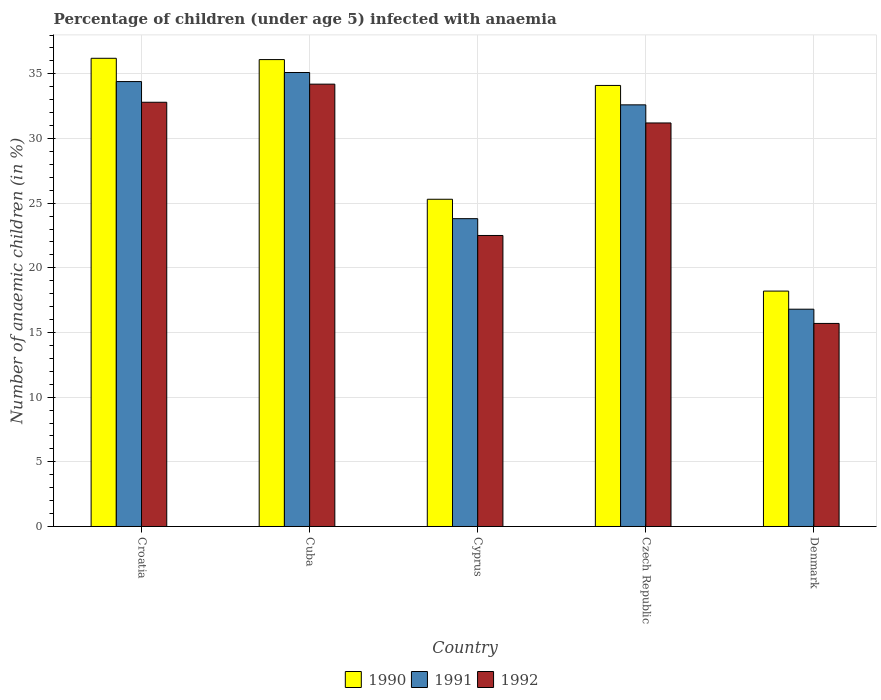How many different coloured bars are there?
Offer a terse response. 3. How many groups of bars are there?
Make the answer very short. 5. Are the number of bars per tick equal to the number of legend labels?
Your response must be concise. Yes. How many bars are there on the 1st tick from the left?
Your response must be concise. 3. How many bars are there on the 3rd tick from the right?
Give a very brief answer. 3. What is the label of the 4th group of bars from the left?
Provide a succinct answer. Czech Republic. What is the percentage of children infected with anaemia in in 1992 in Cuba?
Give a very brief answer. 34.2. Across all countries, what is the maximum percentage of children infected with anaemia in in 1990?
Make the answer very short. 36.2. Across all countries, what is the minimum percentage of children infected with anaemia in in 1991?
Ensure brevity in your answer.  16.8. In which country was the percentage of children infected with anaemia in in 1990 maximum?
Ensure brevity in your answer.  Croatia. In which country was the percentage of children infected with anaemia in in 1992 minimum?
Give a very brief answer. Denmark. What is the total percentage of children infected with anaemia in in 1992 in the graph?
Provide a succinct answer. 136.4. What is the difference between the percentage of children infected with anaemia in in 1991 in Croatia and that in Cuba?
Give a very brief answer. -0.7. What is the difference between the percentage of children infected with anaemia in in 1991 in Cyprus and the percentage of children infected with anaemia in in 1990 in Czech Republic?
Your answer should be compact. -10.3. What is the average percentage of children infected with anaemia in in 1992 per country?
Your response must be concise. 27.28. What is the difference between the percentage of children infected with anaemia in of/in 1991 and percentage of children infected with anaemia in of/in 1992 in Cuba?
Your answer should be compact. 0.9. What is the ratio of the percentage of children infected with anaemia in in 1992 in Cuba to that in Denmark?
Offer a very short reply. 2.18. Is the percentage of children infected with anaemia in in 1992 in Croatia less than that in Denmark?
Ensure brevity in your answer.  No. Is the difference between the percentage of children infected with anaemia in in 1991 in Cuba and Denmark greater than the difference between the percentage of children infected with anaemia in in 1992 in Cuba and Denmark?
Ensure brevity in your answer.  No. What is the difference between the highest and the second highest percentage of children infected with anaemia in in 1990?
Your response must be concise. -2.1. What is the difference between the highest and the lowest percentage of children infected with anaemia in in 1992?
Make the answer very short. 18.5. In how many countries, is the percentage of children infected with anaemia in in 1990 greater than the average percentage of children infected with anaemia in in 1990 taken over all countries?
Offer a very short reply. 3. Is the sum of the percentage of children infected with anaemia in in 1991 in Cyprus and Denmark greater than the maximum percentage of children infected with anaemia in in 1990 across all countries?
Your response must be concise. Yes. What does the 1st bar from the left in Cyprus represents?
Ensure brevity in your answer.  1990. Is it the case that in every country, the sum of the percentage of children infected with anaemia in in 1990 and percentage of children infected with anaemia in in 1991 is greater than the percentage of children infected with anaemia in in 1992?
Offer a terse response. Yes. Are all the bars in the graph horizontal?
Give a very brief answer. No. What is the difference between two consecutive major ticks on the Y-axis?
Give a very brief answer. 5. Does the graph contain any zero values?
Your answer should be compact. No. Does the graph contain grids?
Ensure brevity in your answer.  Yes. Where does the legend appear in the graph?
Offer a terse response. Bottom center. How are the legend labels stacked?
Your answer should be very brief. Horizontal. What is the title of the graph?
Keep it short and to the point. Percentage of children (under age 5) infected with anaemia. What is the label or title of the X-axis?
Provide a short and direct response. Country. What is the label or title of the Y-axis?
Ensure brevity in your answer.  Number of anaemic children (in %). What is the Number of anaemic children (in %) of 1990 in Croatia?
Offer a very short reply. 36.2. What is the Number of anaemic children (in %) in 1991 in Croatia?
Keep it short and to the point. 34.4. What is the Number of anaemic children (in %) of 1992 in Croatia?
Your response must be concise. 32.8. What is the Number of anaemic children (in %) in 1990 in Cuba?
Offer a very short reply. 36.1. What is the Number of anaemic children (in %) of 1991 in Cuba?
Ensure brevity in your answer.  35.1. What is the Number of anaemic children (in %) of 1992 in Cuba?
Your answer should be very brief. 34.2. What is the Number of anaemic children (in %) in 1990 in Cyprus?
Ensure brevity in your answer.  25.3. What is the Number of anaemic children (in %) in 1991 in Cyprus?
Offer a very short reply. 23.8. What is the Number of anaemic children (in %) in 1990 in Czech Republic?
Offer a terse response. 34.1. What is the Number of anaemic children (in %) of 1991 in Czech Republic?
Ensure brevity in your answer.  32.6. What is the Number of anaemic children (in %) in 1992 in Czech Republic?
Make the answer very short. 31.2. Across all countries, what is the maximum Number of anaemic children (in %) of 1990?
Give a very brief answer. 36.2. Across all countries, what is the maximum Number of anaemic children (in %) in 1991?
Give a very brief answer. 35.1. Across all countries, what is the maximum Number of anaemic children (in %) of 1992?
Ensure brevity in your answer.  34.2. Across all countries, what is the minimum Number of anaemic children (in %) of 1991?
Offer a terse response. 16.8. Across all countries, what is the minimum Number of anaemic children (in %) of 1992?
Your response must be concise. 15.7. What is the total Number of anaemic children (in %) in 1990 in the graph?
Ensure brevity in your answer.  149.9. What is the total Number of anaemic children (in %) in 1991 in the graph?
Offer a very short reply. 142.7. What is the total Number of anaemic children (in %) of 1992 in the graph?
Your answer should be very brief. 136.4. What is the difference between the Number of anaemic children (in %) in 1990 in Croatia and that in Cuba?
Offer a very short reply. 0.1. What is the difference between the Number of anaemic children (in %) of 1992 in Croatia and that in Cuba?
Provide a short and direct response. -1.4. What is the difference between the Number of anaemic children (in %) of 1992 in Croatia and that in Cyprus?
Offer a terse response. 10.3. What is the difference between the Number of anaemic children (in %) of 1992 in Croatia and that in Czech Republic?
Ensure brevity in your answer.  1.6. What is the difference between the Number of anaemic children (in %) in 1992 in Cuba and that in Cyprus?
Provide a succinct answer. 11.7. What is the difference between the Number of anaemic children (in %) of 1990 in Cuba and that in Czech Republic?
Your answer should be compact. 2. What is the difference between the Number of anaemic children (in %) in 1992 in Cyprus and that in Denmark?
Make the answer very short. 6.8. What is the difference between the Number of anaemic children (in %) in 1990 in Croatia and the Number of anaemic children (in %) in 1991 in Cuba?
Offer a terse response. 1.1. What is the difference between the Number of anaemic children (in %) of 1990 in Croatia and the Number of anaemic children (in %) of 1991 in Cyprus?
Your response must be concise. 12.4. What is the difference between the Number of anaemic children (in %) in 1990 in Croatia and the Number of anaemic children (in %) in 1991 in Czech Republic?
Make the answer very short. 3.6. What is the difference between the Number of anaemic children (in %) of 1990 in Croatia and the Number of anaemic children (in %) of 1992 in Czech Republic?
Your response must be concise. 5. What is the difference between the Number of anaemic children (in %) in 1991 in Croatia and the Number of anaemic children (in %) in 1992 in Denmark?
Keep it short and to the point. 18.7. What is the difference between the Number of anaemic children (in %) of 1990 in Cuba and the Number of anaemic children (in %) of 1991 in Czech Republic?
Provide a succinct answer. 3.5. What is the difference between the Number of anaemic children (in %) in 1990 in Cuba and the Number of anaemic children (in %) in 1991 in Denmark?
Provide a succinct answer. 19.3. What is the difference between the Number of anaemic children (in %) in 1990 in Cuba and the Number of anaemic children (in %) in 1992 in Denmark?
Ensure brevity in your answer.  20.4. What is the difference between the Number of anaemic children (in %) of 1991 in Cuba and the Number of anaemic children (in %) of 1992 in Denmark?
Provide a short and direct response. 19.4. What is the difference between the Number of anaemic children (in %) of 1991 in Cyprus and the Number of anaemic children (in %) of 1992 in Czech Republic?
Ensure brevity in your answer.  -7.4. What is the difference between the Number of anaemic children (in %) in 1990 in Cyprus and the Number of anaemic children (in %) in 1991 in Denmark?
Provide a short and direct response. 8.5. What is the difference between the Number of anaemic children (in %) of 1990 in Cyprus and the Number of anaemic children (in %) of 1992 in Denmark?
Make the answer very short. 9.6. What is the difference between the Number of anaemic children (in %) in 1991 in Cyprus and the Number of anaemic children (in %) in 1992 in Denmark?
Make the answer very short. 8.1. What is the difference between the Number of anaemic children (in %) in 1990 in Czech Republic and the Number of anaemic children (in %) in 1991 in Denmark?
Make the answer very short. 17.3. What is the difference between the Number of anaemic children (in %) of 1991 in Czech Republic and the Number of anaemic children (in %) of 1992 in Denmark?
Ensure brevity in your answer.  16.9. What is the average Number of anaemic children (in %) in 1990 per country?
Your answer should be compact. 29.98. What is the average Number of anaemic children (in %) in 1991 per country?
Provide a short and direct response. 28.54. What is the average Number of anaemic children (in %) of 1992 per country?
Keep it short and to the point. 27.28. What is the difference between the Number of anaemic children (in %) of 1990 and Number of anaemic children (in %) of 1991 in Cuba?
Ensure brevity in your answer.  1. What is the difference between the Number of anaemic children (in %) of 1990 and Number of anaemic children (in %) of 1992 in Cuba?
Your response must be concise. 1.9. What is the difference between the Number of anaemic children (in %) in 1990 and Number of anaemic children (in %) in 1992 in Czech Republic?
Your answer should be very brief. 2.9. What is the difference between the Number of anaemic children (in %) of 1991 and Number of anaemic children (in %) of 1992 in Czech Republic?
Give a very brief answer. 1.4. What is the difference between the Number of anaemic children (in %) in 1990 and Number of anaemic children (in %) in 1992 in Denmark?
Give a very brief answer. 2.5. What is the ratio of the Number of anaemic children (in %) in 1991 in Croatia to that in Cuba?
Provide a succinct answer. 0.98. What is the ratio of the Number of anaemic children (in %) in 1992 in Croatia to that in Cuba?
Keep it short and to the point. 0.96. What is the ratio of the Number of anaemic children (in %) of 1990 in Croatia to that in Cyprus?
Offer a very short reply. 1.43. What is the ratio of the Number of anaemic children (in %) of 1991 in Croatia to that in Cyprus?
Your answer should be compact. 1.45. What is the ratio of the Number of anaemic children (in %) of 1992 in Croatia to that in Cyprus?
Keep it short and to the point. 1.46. What is the ratio of the Number of anaemic children (in %) in 1990 in Croatia to that in Czech Republic?
Provide a short and direct response. 1.06. What is the ratio of the Number of anaemic children (in %) in 1991 in Croatia to that in Czech Republic?
Ensure brevity in your answer.  1.06. What is the ratio of the Number of anaemic children (in %) in 1992 in Croatia to that in Czech Republic?
Your answer should be compact. 1.05. What is the ratio of the Number of anaemic children (in %) in 1990 in Croatia to that in Denmark?
Your response must be concise. 1.99. What is the ratio of the Number of anaemic children (in %) in 1991 in Croatia to that in Denmark?
Your response must be concise. 2.05. What is the ratio of the Number of anaemic children (in %) of 1992 in Croatia to that in Denmark?
Your answer should be compact. 2.09. What is the ratio of the Number of anaemic children (in %) in 1990 in Cuba to that in Cyprus?
Provide a succinct answer. 1.43. What is the ratio of the Number of anaemic children (in %) in 1991 in Cuba to that in Cyprus?
Provide a short and direct response. 1.47. What is the ratio of the Number of anaemic children (in %) of 1992 in Cuba to that in Cyprus?
Offer a terse response. 1.52. What is the ratio of the Number of anaemic children (in %) of 1990 in Cuba to that in Czech Republic?
Keep it short and to the point. 1.06. What is the ratio of the Number of anaemic children (in %) in 1991 in Cuba to that in Czech Republic?
Offer a terse response. 1.08. What is the ratio of the Number of anaemic children (in %) in 1992 in Cuba to that in Czech Republic?
Your response must be concise. 1.1. What is the ratio of the Number of anaemic children (in %) in 1990 in Cuba to that in Denmark?
Your answer should be very brief. 1.98. What is the ratio of the Number of anaemic children (in %) in 1991 in Cuba to that in Denmark?
Provide a short and direct response. 2.09. What is the ratio of the Number of anaemic children (in %) in 1992 in Cuba to that in Denmark?
Your response must be concise. 2.18. What is the ratio of the Number of anaemic children (in %) of 1990 in Cyprus to that in Czech Republic?
Offer a very short reply. 0.74. What is the ratio of the Number of anaemic children (in %) of 1991 in Cyprus to that in Czech Republic?
Make the answer very short. 0.73. What is the ratio of the Number of anaemic children (in %) of 1992 in Cyprus to that in Czech Republic?
Your answer should be very brief. 0.72. What is the ratio of the Number of anaemic children (in %) in 1990 in Cyprus to that in Denmark?
Ensure brevity in your answer.  1.39. What is the ratio of the Number of anaemic children (in %) of 1991 in Cyprus to that in Denmark?
Your answer should be compact. 1.42. What is the ratio of the Number of anaemic children (in %) in 1992 in Cyprus to that in Denmark?
Keep it short and to the point. 1.43. What is the ratio of the Number of anaemic children (in %) in 1990 in Czech Republic to that in Denmark?
Provide a succinct answer. 1.87. What is the ratio of the Number of anaemic children (in %) of 1991 in Czech Republic to that in Denmark?
Your answer should be compact. 1.94. What is the ratio of the Number of anaemic children (in %) of 1992 in Czech Republic to that in Denmark?
Ensure brevity in your answer.  1.99. What is the difference between the highest and the second highest Number of anaemic children (in %) of 1992?
Your answer should be very brief. 1.4. What is the difference between the highest and the lowest Number of anaemic children (in %) in 1991?
Keep it short and to the point. 18.3. What is the difference between the highest and the lowest Number of anaemic children (in %) of 1992?
Make the answer very short. 18.5. 